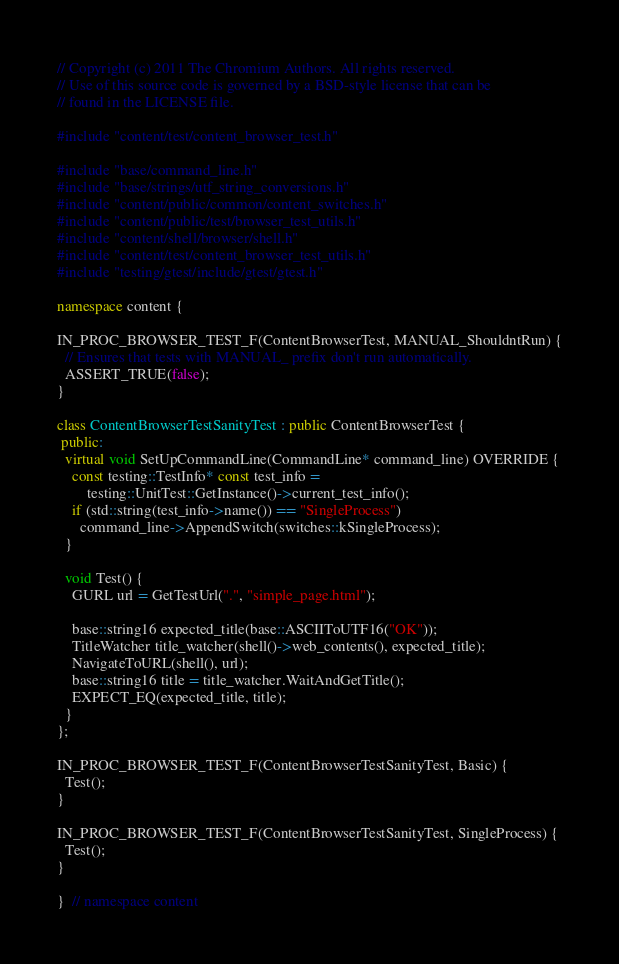<code> <loc_0><loc_0><loc_500><loc_500><_C++_>// Copyright (c) 2011 The Chromium Authors. All rights reserved.
// Use of this source code is governed by a BSD-style license that can be
// found in the LICENSE file.

#include "content/test/content_browser_test.h"

#include "base/command_line.h"
#include "base/strings/utf_string_conversions.h"
#include "content/public/common/content_switches.h"
#include "content/public/test/browser_test_utils.h"
#include "content/shell/browser/shell.h"
#include "content/test/content_browser_test_utils.h"
#include "testing/gtest/include/gtest/gtest.h"

namespace content {

IN_PROC_BROWSER_TEST_F(ContentBrowserTest, MANUAL_ShouldntRun) {
  // Ensures that tests with MANUAL_ prefix don't run automatically.
  ASSERT_TRUE(false);
}

class ContentBrowserTestSanityTest : public ContentBrowserTest {
 public:
  virtual void SetUpCommandLine(CommandLine* command_line) OVERRIDE {
    const testing::TestInfo* const test_info =
        testing::UnitTest::GetInstance()->current_test_info();
    if (std::string(test_info->name()) == "SingleProcess")
      command_line->AppendSwitch(switches::kSingleProcess);
  }

  void Test() {
    GURL url = GetTestUrl(".", "simple_page.html");

    base::string16 expected_title(base::ASCIIToUTF16("OK"));
    TitleWatcher title_watcher(shell()->web_contents(), expected_title);
    NavigateToURL(shell(), url);
    base::string16 title = title_watcher.WaitAndGetTitle();
    EXPECT_EQ(expected_title, title);
  }
};

IN_PROC_BROWSER_TEST_F(ContentBrowserTestSanityTest, Basic) {
  Test();
}

IN_PROC_BROWSER_TEST_F(ContentBrowserTestSanityTest, SingleProcess) {
  Test();
}

}  // namespace content
</code> 